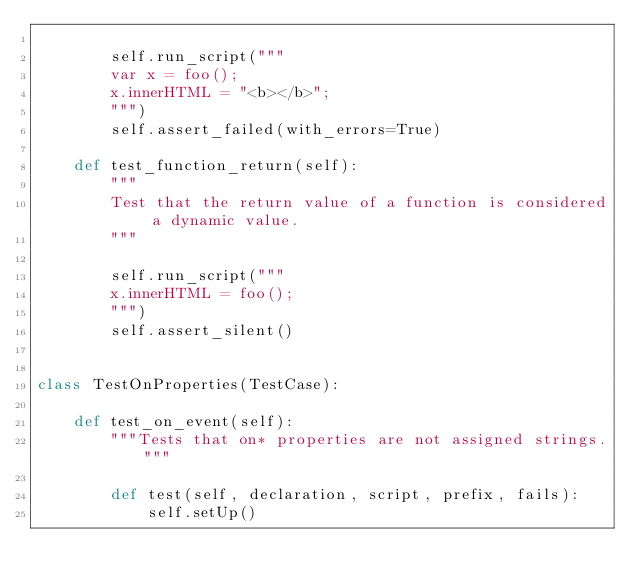Convert code to text. <code><loc_0><loc_0><loc_500><loc_500><_Python_>
        self.run_script("""
        var x = foo();
        x.innerHTML = "<b></b>";
        """)
        self.assert_failed(with_errors=True)

    def test_function_return(self):
        """
        Test that the return value of a function is considered a dynamic value.
        """

        self.run_script("""
        x.innerHTML = foo();
        """)
        self.assert_silent()


class TestOnProperties(TestCase):

    def test_on_event(self):
        """Tests that on* properties are not assigned strings."""

        def test(self, declaration, script, prefix, fails):
            self.setUp()</code> 